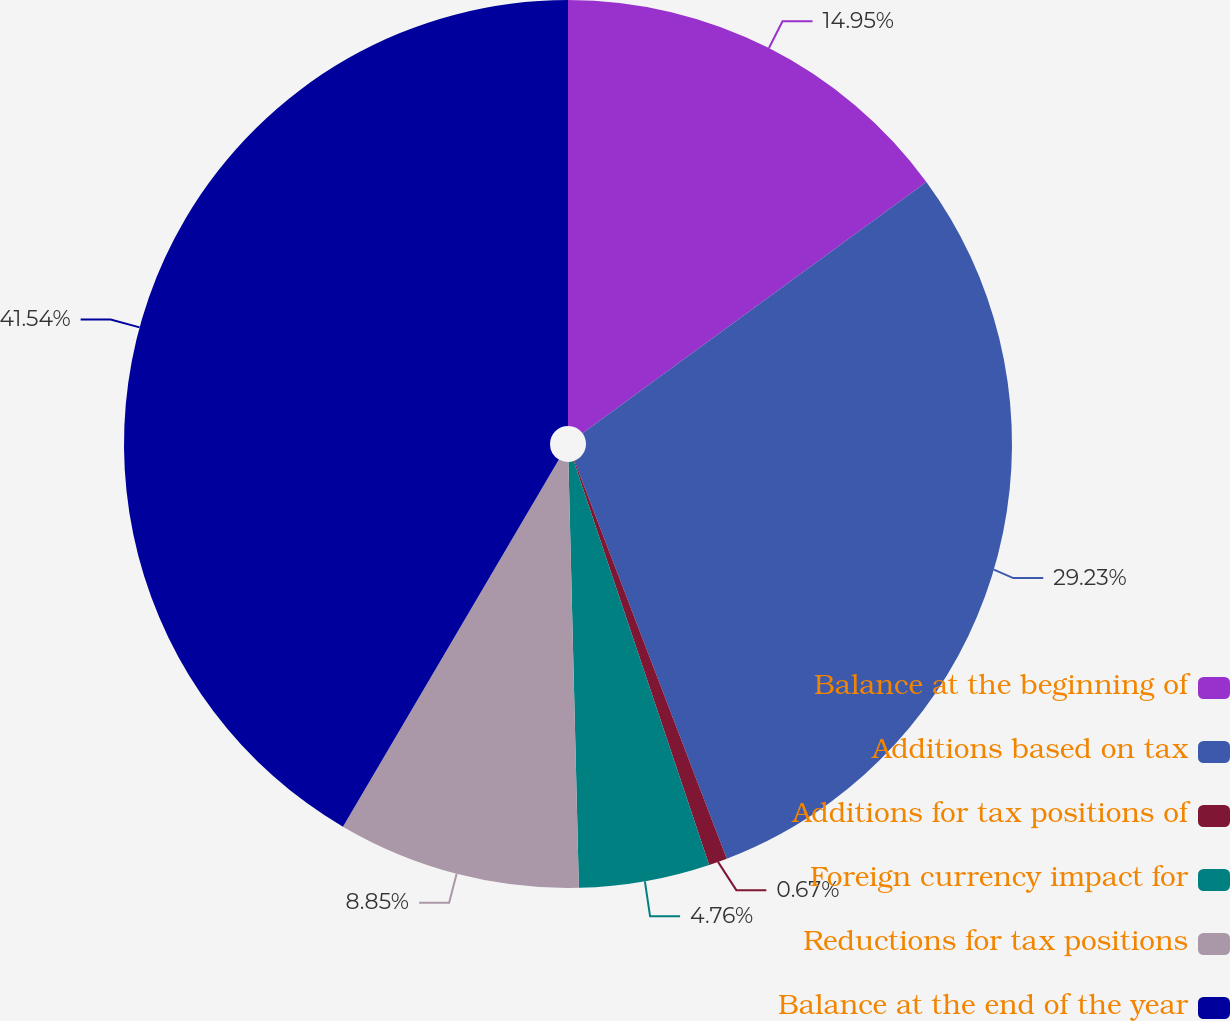Convert chart. <chart><loc_0><loc_0><loc_500><loc_500><pie_chart><fcel>Balance at the beginning of<fcel>Additions based on tax<fcel>Additions for tax positions of<fcel>Foreign currency impact for<fcel>Reductions for tax positions<fcel>Balance at the end of the year<nl><fcel>14.95%<fcel>29.23%<fcel>0.67%<fcel>4.76%<fcel>8.85%<fcel>41.54%<nl></chart> 